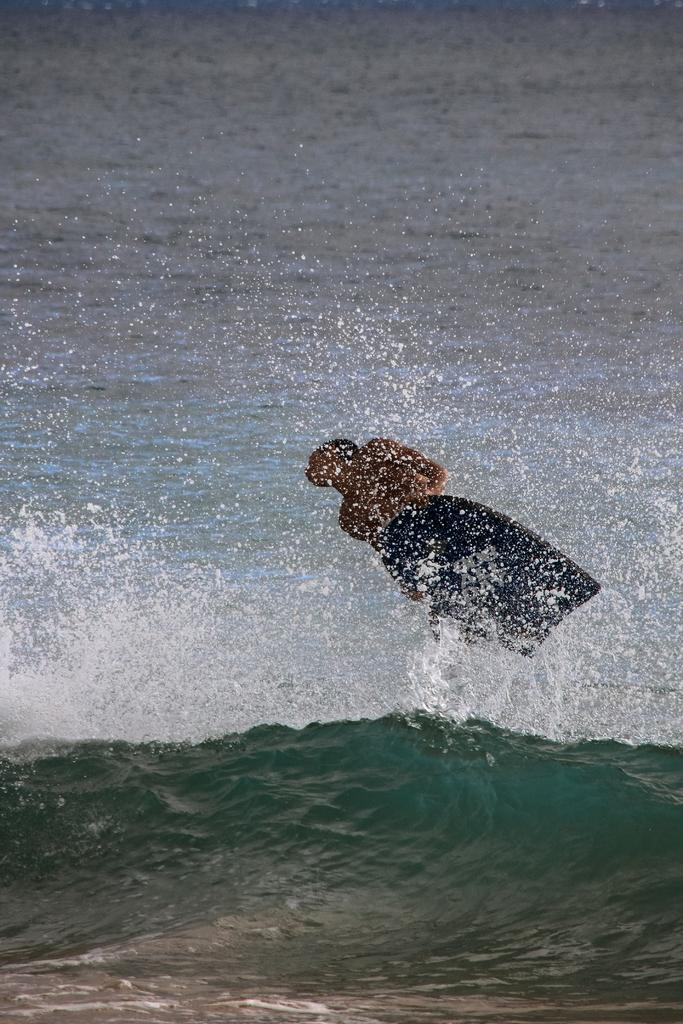What is the main subject of the image? There is a man in the image. What is the man doing in the image? The man is surfing on the water. What does the man's son think about the smell of the water in the image? There is no mention of a son or the smell of the water in the image. 